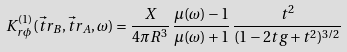Convert formula to latex. <formula><loc_0><loc_0><loc_500><loc_500>K _ { r \phi } ^ { ( 1 ) } ( \vec { t } { r } _ { B } , \vec { t } { r } _ { A } , \omega ) = \frac { X } { 4 \pi R ^ { 3 } } \, \frac { \mu ( \omega ) - 1 } { \mu ( \omega ) + 1 } \, \frac { t ^ { 2 } } { ( 1 - 2 t g + t ^ { 2 } ) ^ { 3 / 2 } }</formula> 